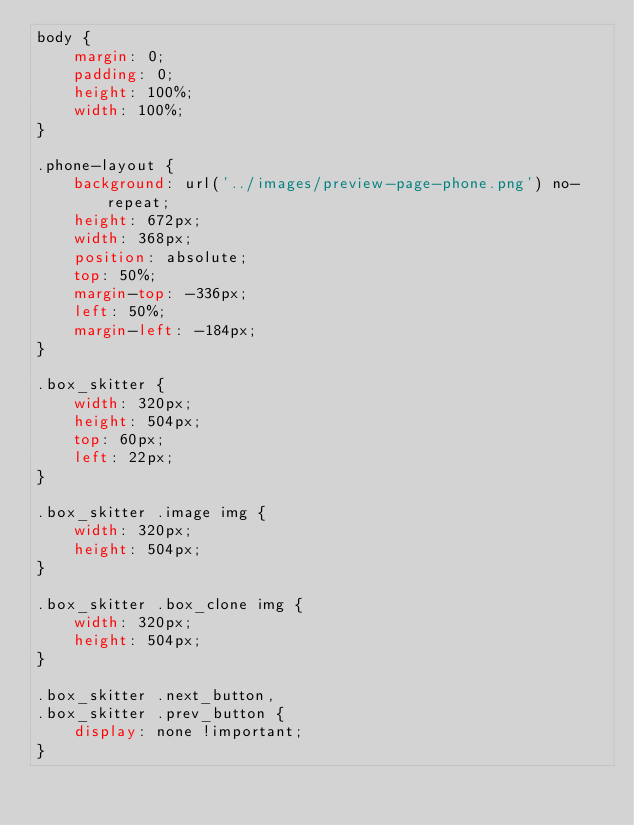Convert code to text. <code><loc_0><loc_0><loc_500><loc_500><_CSS_>body {
    margin: 0;
    padding: 0;
    height: 100%;
    width: 100%;
}

.phone-layout {
    background: url('../images/preview-page-phone.png') no-repeat;
    height: 672px;
    width: 368px;
    position: absolute;
    top: 50%;
    margin-top: -336px;
    left: 50%;
    margin-left: -184px;
}

.box_skitter {
    width: 320px;
    height: 504px;
    top: 60px;
    left: 22px;
}

.box_skitter .image img {
    width: 320px;
    height: 504px;
}

.box_skitter .box_clone img {
    width: 320px;
    height: 504px;
}

.box_skitter .next_button,
.box_skitter .prev_button {
    display: none !important;
}

</code> 